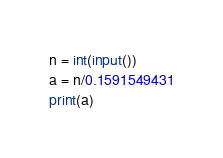<code> <loc_0><loc_0><loc_500><loc_500><_Python_>n = int(input())
a = n/0.1591549431
print(a)
</code> 